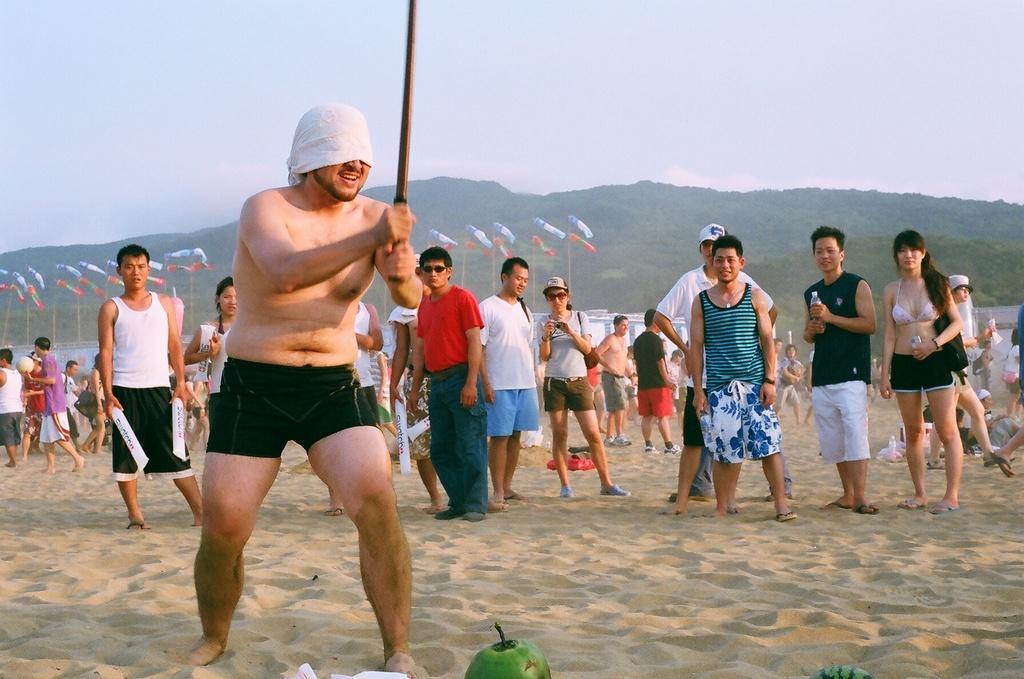In one or two sentences, can you explain what this image depicts? There is a man holding a bamboo and cloth on his face, there are some objects at the bottom side in the foreground area of the image, there are people, poles, water, mountains and the sky in the background. 